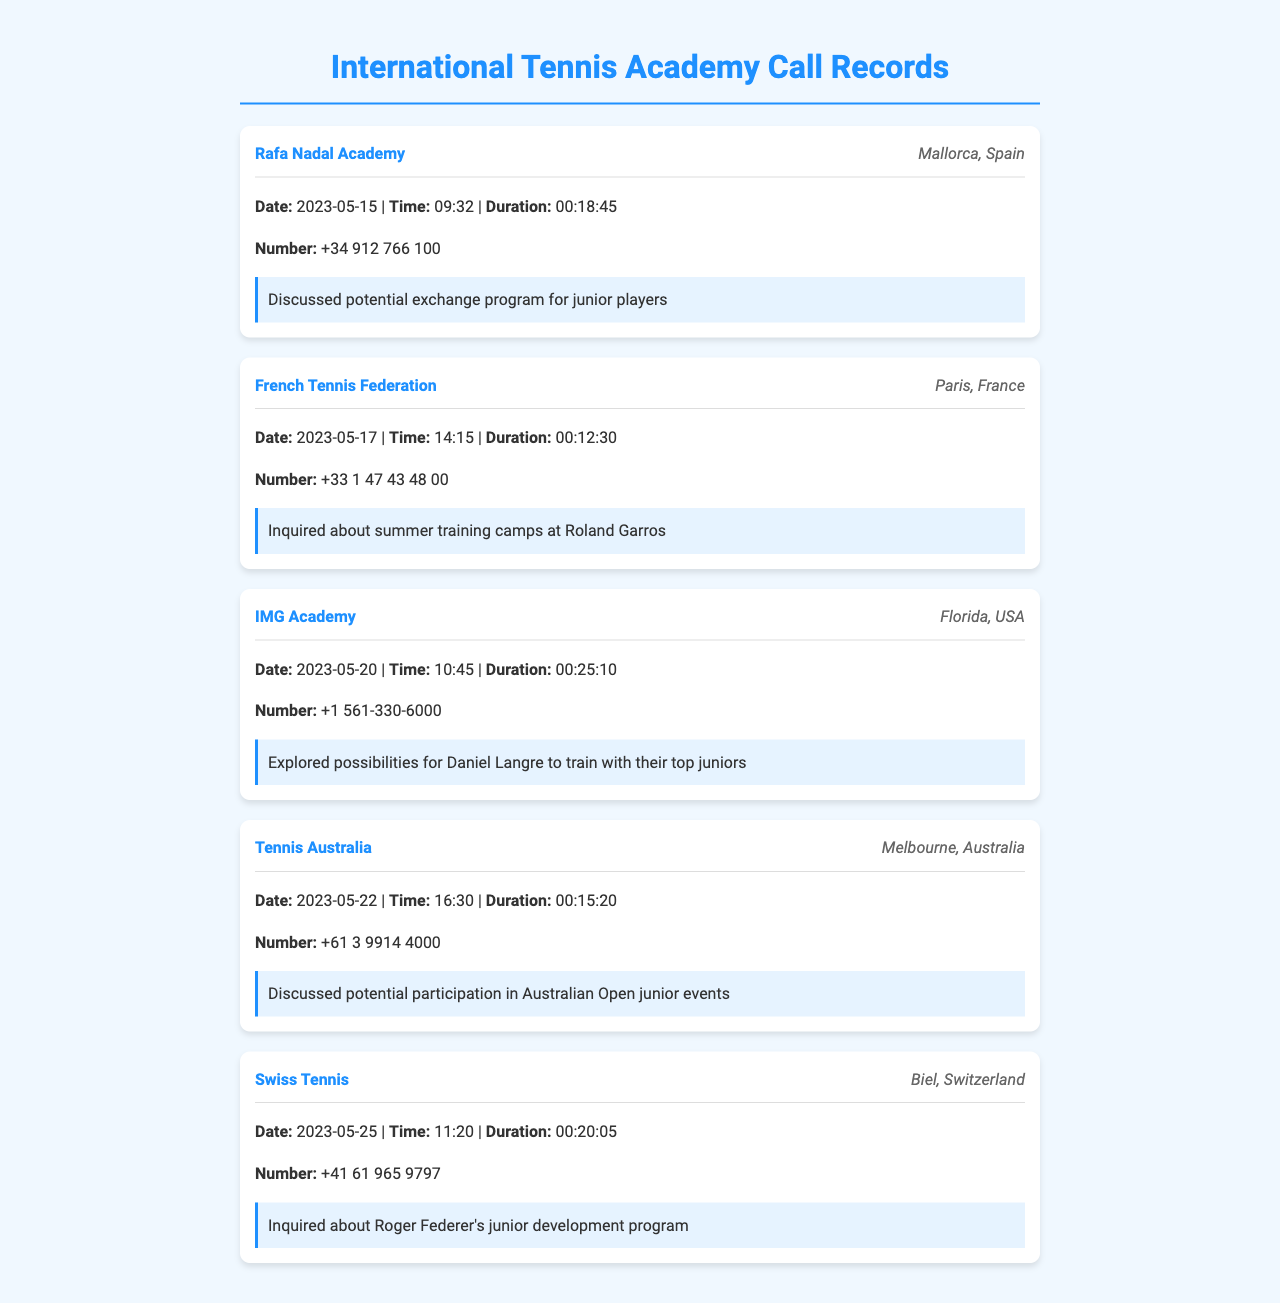What is the contact name of the first academy? The contact name of the first academy listed is Rafa Nadal Academy.
Answer: Rafa Nadal Academy What is the location of IMG Academy? The location of IMG Academy is in Florida, USA.
Answer: Florida, USA What date was the call made to Swiss Tennis? The call to Swiss Tennis was made on May 25, 2023.
Answer: 2023-05-25 How long was the call to French Tennis Federation? The duration of the call to French Tennis Federation was 12 minutes and 30 seconds.
Answer: 00:12:30 What potential program was discussed during the call to the Rafa Nadal Academy? The potential program discussed was an exchange program for junior players.
Answer: exchange program for junior players What was inquired about during the call to Swiss Tennis? During the call to Swiss Tennis, an inquiry was made about Roger Federer's junior development program.
Answer: Roger Federer's junior development program How many minutes long was the call to Tennis Australia? The call to Tennis Australia lasted for 15 minutes and 20 seconds.
Answer: 00:15:20 What was the focus of discussion during the call to IMG Academy? The focus of the discussion during the call to IMG Academy was the possibilities for Daniel Langre to train with their top juniors.
Answer: possibilities for Daniel Langre to train with their top juniors 